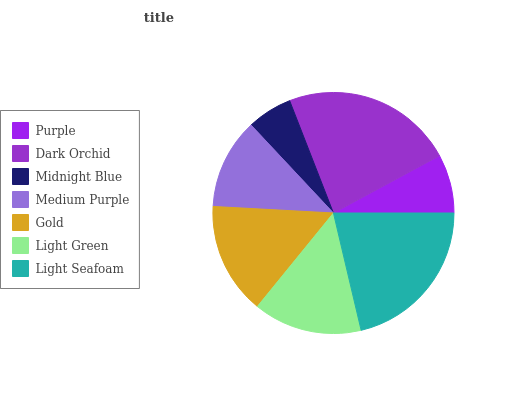Is Midnight Blue the minimum?
Answer yes or no. Yes. Is Dark Orchid the maximum?
Answer yes or no. Yes. Is Dark Orchid the minimum?
Answer yes or no. No. Is Midnight Blue the maximum?
Answer yes or no. No. Is Dark Orchid greater than Midnight Blue?
Answer yes or no. Yes. Is Midnight Blue less than Dark Orchid?
Answer yes or no. Yes. Is Midnight Blue greater than Dark Orchid?
Answer yes or no. No. Is Dark Orchid less than Midnight Blue?
Answer yes or no. No. Is Light Green the high median?
Answer yes or no. Yes. Is Light Green the low median?
Answer yes or no. Yes. Is Midnight Blue the high median?
Answer yes or no. No. Is Light Seafoam the low median?
Answer yes or no. No. 